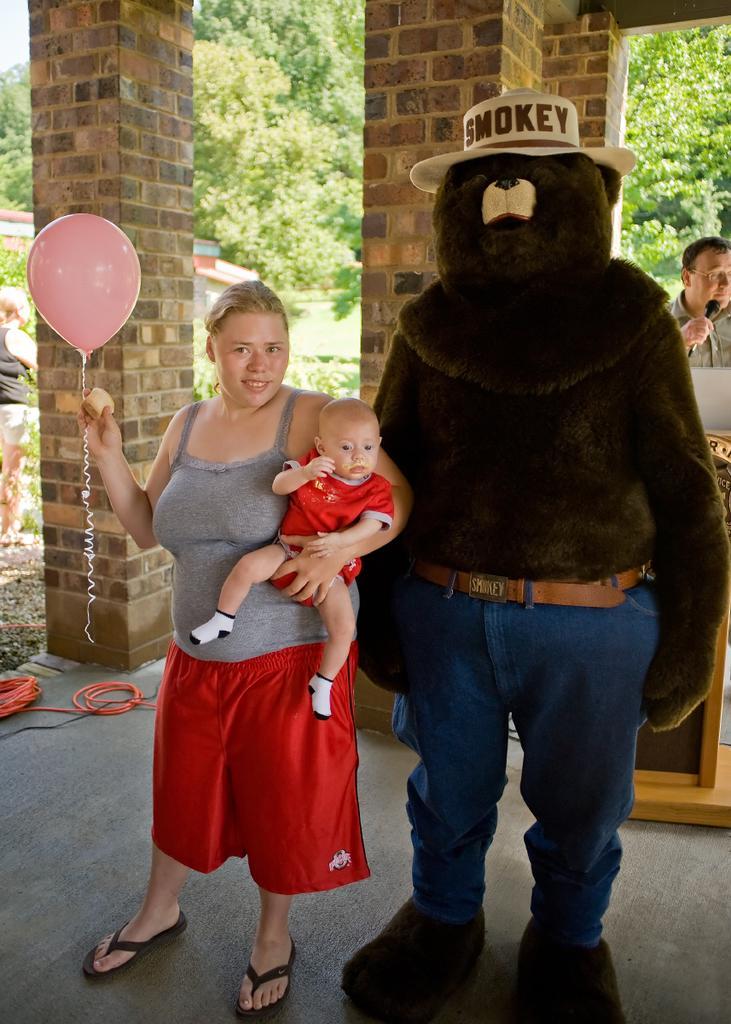Can you describe this image briefly? In the foreground I can see a woman is holding a baby and a balloon in hand and a person in costume. In the background I can see pillars, wall, house, trees and two persons. This image is taken may be during a day. 